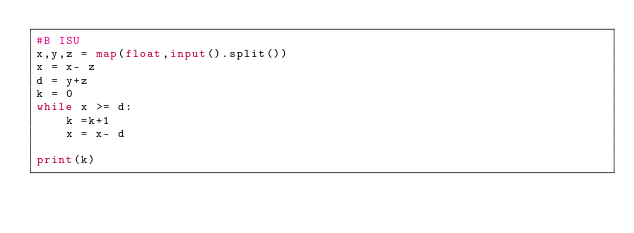<code> <loc_0><loc_0><loc_500><loc_500><_Python_>#B ISU
x,y,z = map(float,input().split())
x = x- z
d = y+z
k = 0
while x >= d:
    k =k+1
    x = x- d
    
print(k)
    
    </code> 